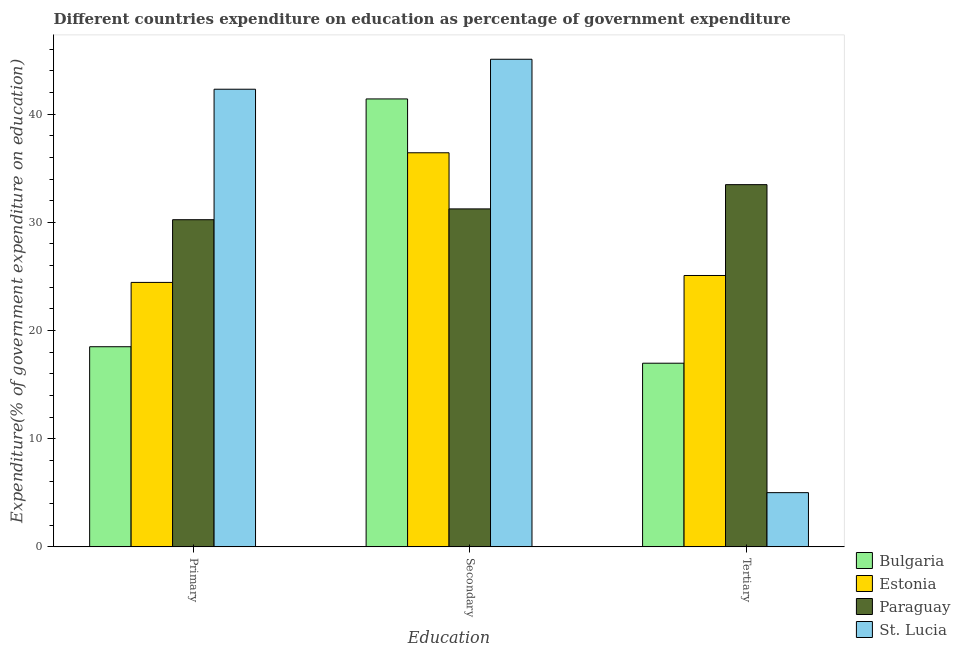How many bars are there on the 1st tick from the right?
Your response must be concise. 4. What is the label of the 1st group of bars from the left?
Your response must be concise. Primary. What is the expenditure on secondary education in Paraguay?
Provide a short and direct response. 31.24. Across all countries, what is the maximum expenditure on secondary education?
Ensure brevity in your answer.  45.08. Across all countries, what is the minimum expenditure on secondary education?
Ensure brevity in your answer.  31.24. In which country was the expenditure on tertiary education maximum?
Make the answer very short. Paraguay. In which country was the expenditure on secondary education minimum?
Your answer should be compact. Paraguay. What is the total expenditure on primary education in the graph?
Give a very brief answer. 115.49. What is the difference between the expenditure on primary education in Estonia and that in St. Lucia?
Your answer should be very brief. -17.86. What is the difference between the expenditure on tertiary education in Paraguay and the expenditure on primary education in Bulgaria?
Give a very brief answer. 14.98. What is the average expenditure on primary education per country?
Ensure brevity in your answer.  28.87. What is the difference between the expenditure on tertiary education and expenditure on secondary education in Estonia?
Offer a very short reply. -11.34. In how many countries, is the expenditure on tertiary education greater than 44 %?
Provide a short and direct response. 0. What is the ratio of the expenditure on secondary education in Estonia to that in Bulgaria?
Your response must be concise. 0.88. Is the expenditure on tertiary education in St. Lucia less than that in Bulgaria?
Offer a very short reply. Yes. Is the difference between the expenditure on secondary education in Estonia and Bulgaria greater than the difference between the expenditure on primary education in Estonia and Bulgaria?
Make the answer very short. No. What is the difference between the highest and the second highest expenditure on primary education?
Offer a terse response. 12.06. What is the difference between the highest and the lowest expenditure on tertiary education?
Keep it short and to the point. 28.47. In how many countries, is the expenditure on secondary education greater than the average expenditure on secondary education taken over all countries?
Your response must be concise. 2. Is the sum of the expenditure on tertiary education in Bulgaria and St. Lucia greater than the maximum expenditure on secondary education across all countries?
Provide a short and direct response. No. What does the 4th bar from the left in Tertiary represents?
Keep it short and to the point. St. Lucia. What does the 3rd bar from the right in Tertiary represents?
Provide a short and direct response. Estonia. How many bars are there?
Provide a succinct answer. 12. How many countries are there in the graph?
Your response must be concise. 4. What is the difference between two consecutive major ticks on the Y-axis?
Keep it short and to the point. 10. Does the graph contain grids?
Keep it short and to the point. No. Where does the legend appear in the graph?
Provide a succinct answer. Bottom right. How many legend labels are there?
Provide a short and direct response. 4. What is the title of the graph?
Your answer should be compact. Different countries expenditure on education as percentage of government expenditure. Does "Russian Federation" appear as one of the legend labels in the graph?
Make the answer very short. No. What is the label or title of the X-axis?
Provide a succinct answer. Education. What is the label or title of the Y-axis?
Your answer should be compact. Expenditure(% of government expenditure on education). What is the Expenditure(% of government expenditure on education) of Bulgaria in Primary?
Provide a short and direct response. 18.5. What is the Expenditure(% of government expenditure on education) in Estonia in Primary?
Give a very brief answer. 24.45. What is the Expenditure(% of government expenditure on education) of Paraguay in Primary?
Provide a short and direct response. 30.24. What is the Expenditure(% of government expenditure on education) of St. Lucia in Primary?
Ensure brevity in your answer.  42.3. What is the Expenditure(% of government expenditure on education) in Bulgaria in Secondary?
Offer a very short reply. 41.41. What is the Expenditure(% of government expenditure on education) in Estonia in Secondary?
Offer a terse response. 36.43. What is the Expenditure(% of government expenditure on education) of Paraguay in Secondary?
Provide a short and direct response. 31.24. What is the Expenditure(% of government expenditure on education) in St. Lucia in Secondary?
Ensure brevity in your answer.  45.08. What is the Expenditure(% of government expenditure on education) of Bulgaria in Tertiary?
Your answer should be compact. 16.98. What is the Expenditure(% of government expenditure on education) of Estonia in Tertiary?
Provide a short and direct response. 25.09. What is the Expenditure(% of government expenditure on education) of Paraguay in Tertiary?
Provide a short and direct response. 33.48. What is the Expenditure(% of government expenditure on education) in St. Lucia in Tertiary?
Keep it short and to the point. 5.01. Across all Education, what is the maximum Expenditure(% of government expenditure on education) in Bulgaria?
Make the answer very short. 41.41. Across all Education, what is the maximum Expenditure(% of government expenditure on education) in Estonia?
Ensure brevity in your answer.  36.43. Across all Education, what is the maximum Expenditure(% of government expenditure on education) in Paraguay?
Your response must be concise. 33.48. Across all Education, what is the maximum Expenditure(% of government expenditure on education) in St. Lucia?
Make the answer very short. 45.08. Across all Education, what is the minimum Expenditure(% of government expenditure on education) in Bulgaria?
Give a very brief answer. 16.98. Across all Education, what is the minimum Expenditure(% of government expenditure on education) in Estonia?
Keep it short and to the point. 24.45. Across all Education, what is the minimum Expenditure(% of government expenditure on education) in Paraguay?
Offer a very short reply. 30.24. Across all Education, what is the minimum Expenditure(% of government expenditure on education) of St. Lucia?
Your answer should be compact. 5.01. What is the total Expenditure(% of government expenditure on education) in Bulgaria in the graph?
Ensure brevity in your answer.  76.89. What is the total Expenditure(% of government expenditure on education) in Estonia in the graph?
Your answer should be very brief. 85.96. What is the total Expenditure(% of government expenditure on education) in Paraguay in the graph?
Make the answer very short. 94.97. What is the total Expenditure(% of government expenditure on education) of St. Lucia in the graph?
Your answer should be compact. 92.39. What is the difference between the Expenditure(% of government expenditure on education) of Bulgaria in Primary and that in Secondary?
Provide a short and direct response. -22.91. What is the difference between the Expenditure(% of government expenditure on education) in Estonia in Primary and that in Secondary?
Provide a succinct answer. -11.98. What is the difference between the Expenditure(% of government expenditure on education) in Paraguay in Primary and that in Secondary?
Offer a very short reply. -1. What is the difference between the Expenditure(% of government expenditure on education) in St. Lucia in Primary and that in Secondary?
Offer a very short reply. -2.77. What is the difference between the Expenditure(% of government expenditure on education) of Bulgaria in Primary and that in Tertiary?
Offer a very short reply. 1.52. What is the difference between the Expenditure(% of government expenditure on education) of Estonia in Primary and that in Tertiary?
Your response must be concise. -0.64. What is the difference between the Expenditure(% of government expenditure on education) of Paraguay in Primary and that in Tertiary?
Your answer should be very brief. -3.24. What is the difference between the Expenditure(% of government expenditure on education) in St. Lucia in Primary and that in Tertiary?
Your answer should be very brief. 37.29. What is the difference between the Expenditure(% of government expenditure on education) in Bulgaria in Secondary and that in Tertiary?
Keep it short and to the point. 24.43. What is the difference between the Expenditure(% of government expenditure on education) in Estonia in Secondary and that in Tertiary?
Make the answer very short. 11.34. What is the difference between the Expenditure(% of government expenditure on education) of Paraguay in Secondary and that in Tertiary?
Make the answer very short. -2.24. What is the difference between the Expenditure(% of government expenditure on education) in St. Lucia in Secondary and that in Tertiary?
Your response must be concise. 40.06. What is the difference between the Expenditure(% of government expenditure on education) of Bulgaria in Primary and the Expenditure(% of government expenditure on education) of Estonia in Secondary?
Your answer should be very brief. -17.93. What is the difference between the Expenditure(% of government expenditure on education) of Bulgaria in Primary and the Expenditure(% of government expenditure on education) of Paraguay in Secondary?
Ensure brevity in your answer.  -12.74. What is the difference between the Expenditure(% of government expenditure on education) in Bulgaria in Primary and the Expenditure(% of government expenditure on education) in St. Lucia in Secondary?
Offer a very short reply. -26.58. What is the difference between the Expenditure(% of government expenditure on education) of Estonia in Primary and the Expenditure(% of government expenditure on education) of Paraguay in Secondary?
Ensure brevity in your answer.  -6.8. What is the difference between the Expenditure(% of government expenditure on education) of Estonia in Primary and the Expenditure(% of government expenditure on education) of St. Lucia in Secondary?
Offer a terse response. -20.63. What is the difference between the Expenditure(% of government expenditure on education) of Paraguay in Primary and the Expenditure(% of government expenditure on education) of St. Lucia in Secondary?
Keep it short and to the point. -14.83. What is the difference between the Expenditure(% of government expenditure on education) of Bulgaria in Primary and the Expenditure(% of government expenditure on education) of Estonia in Tertiary?
Offer a terse response. -6.59. What is the difference between the Expenditure(% of government expenditure on education) in Bulgaria in Primary and the Expenditure(% of government expenditure on education) in Paraguay in Tertiary?
Keep it short and to the point. -14.98. What is the difference between the Expenditure(% of government expenditure on education) of Bulgaria in Primary and the Expenditure(% of government expenditure on education) of St. Lucia in Tertiary?
Provide a short and direct response. 13.49. What is the difference between the Expenditure(% of government expenditure on education) of Estonia in Primary and the Expenditure(% of government expenditure on education) of Paraguay in Tertiary?
Your answer should be very brief. -9.04. What is the difference between the Expenditure(% of government expenditure on education) in Estonia in Primary and the Expenditure(% of government expenditure on education) in St. Lucia in Tertiary?
Provide a succinct answer. 19.43. What is the difference between the Expenditure(% of government expenditure on education) of Paraguay in Primary and the Expenditure(% of government expenditure on education) of St. Lucia in Tertiary?
Ensure brevity in your answer.  25.23. What is the difference between the Expenditure(% of government expenditure on education) of Bulgaria in Secondary and the Expenditure(% of government expenditure on education) of Estonia in Tertiary?
Your response must be concise. 16.32. What is the difference between the Expenditure(% of government expenditure on education) in Bulgaria in Secondary and the Expenditure(% of government expenditure on education) in Paraguay in Tertiary?
Give a very brief answer. 7.92. What is the difference between the Expenditure(% of government expenditure on education) of Bulgaria in Secondary and the Expenditure(% of government expenditure on education) of St. Lucia in Tertiary?
Your answer should be compact. 36.4. What is the difference between the Expenditure(% of government expenditure on education) in Estonia in Secondary and the Expenditure(% of government expenditure on education) in Paraguay in Tertiary?
Make the answer very short. 2.95. What is the difference between the Expenditure(% of government expenditure on education) in Estonia in Secondary and the Expenditure(% of government expenditure on education) in St. Lucia in Tertiary?
Offer a terse response. 31.42. What is the difference between the Expenditure(% of government expenditure on education) in Paraguay in Secondary and the Expenditure(% of government expenditure on education) in St. Lucia in Tertiary?
Offer a very short reply. 26.23. What is the average Expenditure(% of government expenditure on education) of Bulgaria per Education?
Provide a short and direct response. 25.63. What is the average Expenditure(% of government expenditure on education) of Estonia per Education?
Your answer should be very brief. 28.65. What is the average Expenditure(% of government expenditure on education) of Paraguay per Education?
Your response must be concise. 31.66. What is the average Expenditure(% of government expenditure on education) in St. Lucia per Education?
Your answer should be compact. 30.8. What is the difference between the Expenditure(% of government expenditure on education) in Bulgaria and Expenditure(% of government expenditure on education) in Estonia in Primary?
Offer a terse response. -5.94. What is the difference between the Expenditure(% of government expenditure on education) in Bulgaria and Expenditure(% of government expenditure on education) in Paraguay in Primary?
Ensure brevity in your answer.  -11.74. What is the difference between the Expenditure(% of government expenditure on education) of Bulgaria and Expenditure(% of government expenditure on education) of St. Lucia in Primary?
Provide a short and direct response. -23.8. What is the difference between the Expenditure(% of government expenditure on education) in Estonia and Expenditure(% of government expenditure on education) in Paraguay in Primary?
Keep it short and to the point. -5.8. What is the difference between the Expenditure(% of government expenditure on education) of Estonia and Expenditure(% of government expenditure on education) of St. Lucia in Primary?
Offer a terse response. -17.86. What is the difference between the Expenditure(% of government expenditure on education) in Paraguay and Expenditure(% of government expenditure on education) in St. Lucia in Primary?
Offer a very short reply. -12.06. What is the difference between the Expenditure(% of government expenditure on education) in Bulgaria and Expenditure(% of government expenditure on education) in Estonia in Secondary?
Offer a terse response. 4.98. What is the difference between the Expenditure(% of government expenditure on education) of Bulgaria and Expenditure(% of government expenditure on education) of Paraguay in Secondary?
Keep it short and to the point. 10.17. What is the difference between the Expenditure(% of government expenditure on education) of Bulgaria and Expenditure(% of government expenditure on education) of St. Lucia in Secondary?
Your answer should be compact. -3.67. What is the difference between the Expenditure(% of government expenditure on education) in Estonia and Expenditure(% of government expenditure on education) in Paraguay in Secondary?
Offer a terse response. 5.19. What is the difference between the Expenditure(% of government expenditure on education) in Estonia and Expenditure(% of government expenditure on education) in St. Lucia in Secondary?
Offer a terse response. -8.65. What is the difference between the Expenditure(% of government expenditure on education) in Paraguay and Expenditure(% of government expenditure on education) in St. Lucia in Secondary?
Keep it short and to the point. -13.83. What is the difference between the Expenditure(% of government expenditure on education) of Bulgaria and Expenditure(% of government expenditure on education) of Estonia in Tertiary?
Your answer should be compact. -8.11. What is the difference between the Expenditure(% of government expenditure on education) in Bulgaria and Expenditure(% of government expenditure on education) in Paraguay in Tertiary?
Offer a very short reply. -16.51. What is the difference between the Expenditure(% of government expenditure on education) in Bulgaria and Expenditure(% of government expenditure on education) in St. Lucia in Tertiary?
Give a very brief answer. 11.97. What is the difference between the Expenditure(% of government expenditure on education) in Estonia and Expenditure(% of government expenditure on education) in Paraguay in Tertiary?
Offer a very short reply. -8.4. What is the difference between the Expenditure(% of government expenditure on education) of Estonia and Expenditure(% of government expenditure on education) of St. Lucia in Tertiary?
Make the answer very short. 20.07. What is the difference between the Expenditure(% of government expenditure on education) of Paraguay and Expenditure(% of government expenditure on education) of St. Lucia in Tertiary?
Provide a succinct answer. 28.47. What is the ratio of the Expenditure(% of government expenditure on education) of Bulgaria in Primary to that in Secondary?
Your answer should be very brief. 0.45. What is the ratio of the Expenditure(% of government expenditure on education) of Estonia in Primary to that in Secondary?
Offer a terse response. 0.67. What is the ratio of the Expenditure(% of government expenditure on education) of St. Lucia in Primary to that in Secondary?
Your response must be concise. 0.94. What is the ratio of the Expenditure(% of government expenditure on education) in Bulgaria in Primary to that in Tertiary?
Make the answer very short. 1.09. What is the ratio of the Expenditure(% of government expenditure on education) in Estonia in Primary to that in Tertiary?
Give a very brief answer. 0.97. What is the ratio of the Expenditure(% of government expenditure on education) in Paraguay in Primary to that in Tertiary?
Offer a terse response. 0.9. What is the ratio of the Expenditure(% of government expenditure on education) in St. Lucia in Primary to that in Tertiary?
Keep it short and to the point. 8.44. What is the ratio of the Expenditure(% of government expenditure on education) of Bulgaria in Secondary to that in Tertiary?
Offer a very short reply. 2.44. What is the ratio of the Expenditure(% of government expenditure on education) in Estonia in Secondary to that in Tertiary?
Ensure brevity in your answer.  1.45. What is the ratio of the Expenditure(% of government expenditure on education) in Paraguay in Secondary to that in Tertiary?
Keep it short and to the point. 0.93. What is the ratio of the Expenditure(% of government expenditure on education) in St. Lucia in Secondary to that in Tertiary?
Ensure brevity in your answer.  9. What is the difference between the highest and the second highest Expenditure(% of government expenditure on education) of Bulgaria?
Keep it short and to the point. 22.91. What is the difference between the highest and the second highest Expenditure(% of government expenditure on education) in Estonia?
Provide a succinct answer. 11.34. What is the difference between the highest and the second highest Expenditure(% of government expenditure on education) of Paraguay?
Provide a short and direct response. 2.24. What is the difference between the highest and the second highest Expenditure(% of government expenditure on education) in St. Lucia?
Provide a succinct answer. 2.77. What is the difference between the highest and the lowest Expenditure(% of government expenditure on education) in Bulgaria?
Offer a terse response. 24.43. What is the difference between the highest and the lowest Expenditure(% of government expenditure on education) of Estonia?
Offer a very short reply. 11.98. What is the difference between the highest and the lowest Expenditure(% of government expenditure on education) of Paraguay?
Your response must be concise. 3.24. What is the difference between the highest and the lowest Expenditure(% of government expenditure on education) in St. Lucia?
Your answer should be very brief. 40.06. 